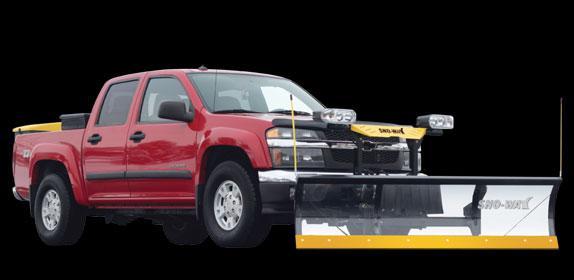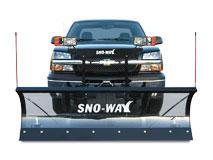The first image is the image on the left, the second image is the image on the right. Evaluate the accuracy of this statement regarding the images: "All of the plows are black with a yellow border.". Is it true? Answer yes or no. No. 